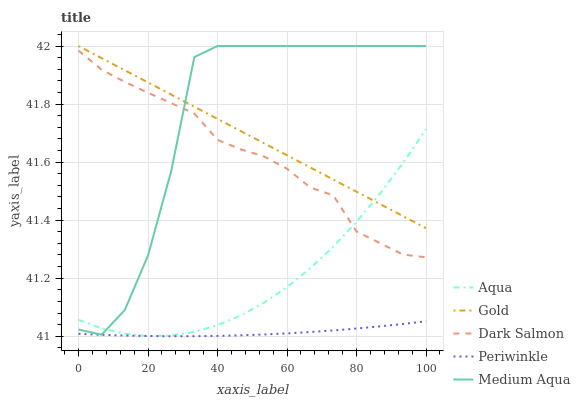Does Periwinkle have the minimum area under the curve?
Answer yes or no. Yes. Does Medium Aqua have the maximum area under the curve?
Answer yes or no. Yes. Does Aqua have the minimum area under the curve?
Answer yes or no. No. Does Aqua have the maximum area under the curve?
Answer yes or no. No. Is Gold the smoothest?
Answer yes or no. Yes. Is Medium Aqua the roughest?
Answer yes or no. Yes. Is Periwinkle the smoothest?
Answer yes or no. No. Is Periwinkle the roughest?
Answer yes or no. No. Does Periwinkle have the lowest value?
Answer yes or no. Yes. Does Aqua have the lowest value?
Answer yes or no. No. Does Gold have the highest value?
Answer yes or no. Yes. Does Aqua have the highest value?
Answer yes or no. No. Is Periwinkle less than Medium Aqua?
Answer yes or no. Yes. Is Dark Salmon greater than Periwinkle?
Answer yes or no. Yes. Does Medium Aqua intersect Dark Salmon?
Answer yes or no. Yes. Is Medium Aqua less than Dark Salmon?
Answer yes or no. No. Is Medium Aqua greater than Dark Salmon?
Answer yes or no. No. Does Periwinkle intersect Medium Aqua?
Answer yes or no. No. 